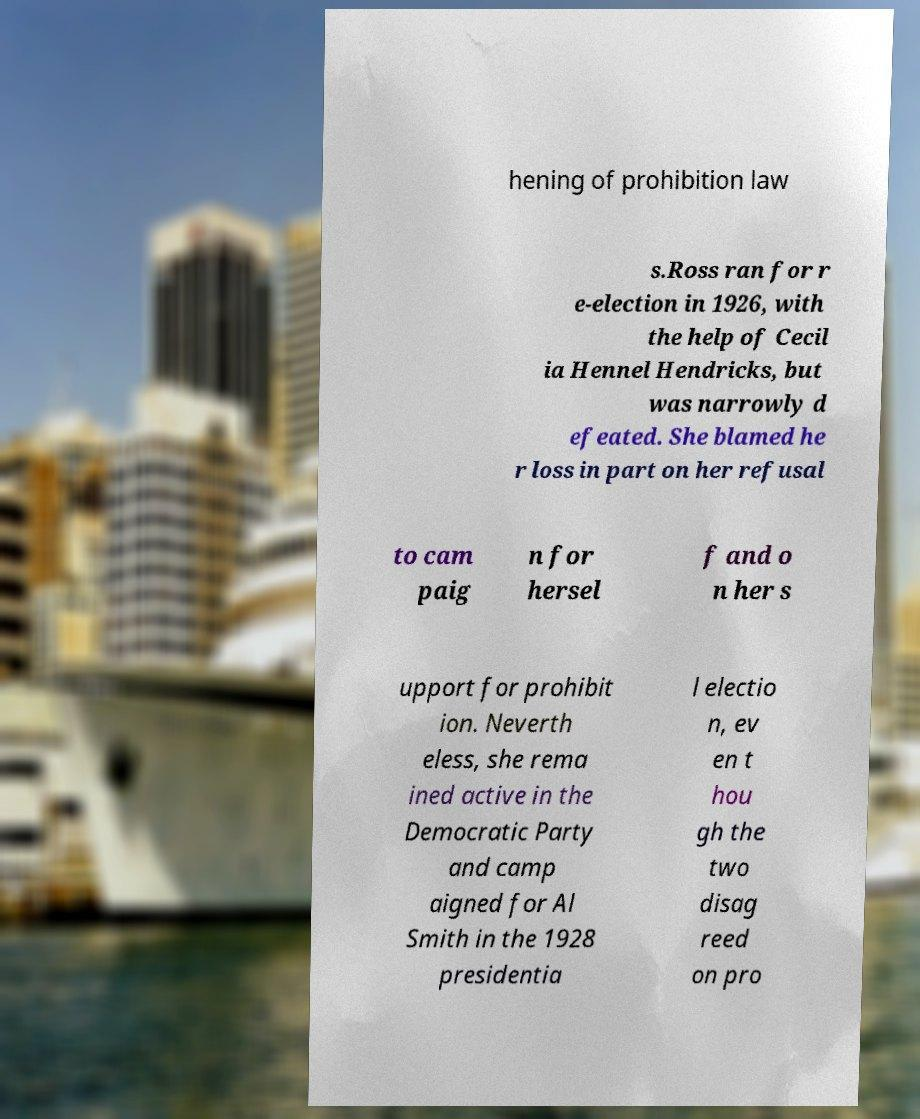Can you read and provide the text displayed in the image?This photo seems to have some interesting text. Can you extract and type it out for me? hening of prohibition law s.Ross ran for r e-election in 1926, with the help of Cecil ia Hennel Hendricks, but was narrowly d efeated. She blamed he r loss in part on her refusal to cam paig n for hersel f and o n her s upport for prohibit ion. Neverth eless, she rema ined active in the Democratic Party and camp aigned for Al Smith in the 1928 presidentia l electio n, ev en t hou gh the two disag reed on pro 